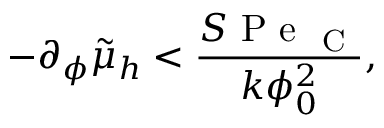Convert formula to latex. <formula><loc_0><loc_0><loc_500><loc_500>- \partial _ { \phi } \tilde { \mu } _ { h } < \frac { S P e _ { C } } { k \phi _ { 0 } ^ { 2 } } ,</formula> 